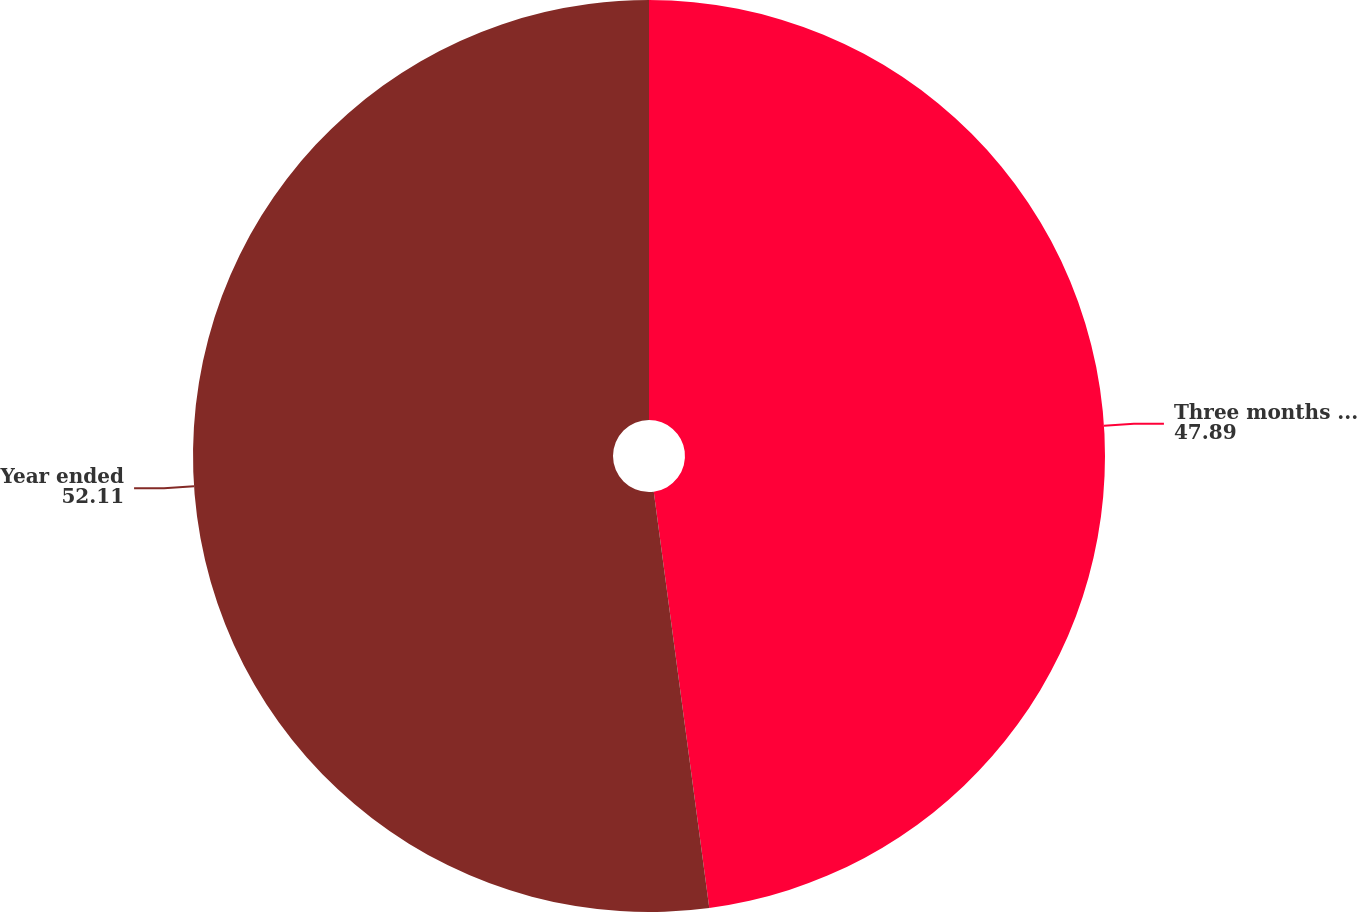<chart> <loc_0><loc_0><loc_500><loc_500><pie_chart><fcel>Three months ended<fcel>Year ended<nl><fcel>47.89%<fcel>52.11%<nl></chart> 